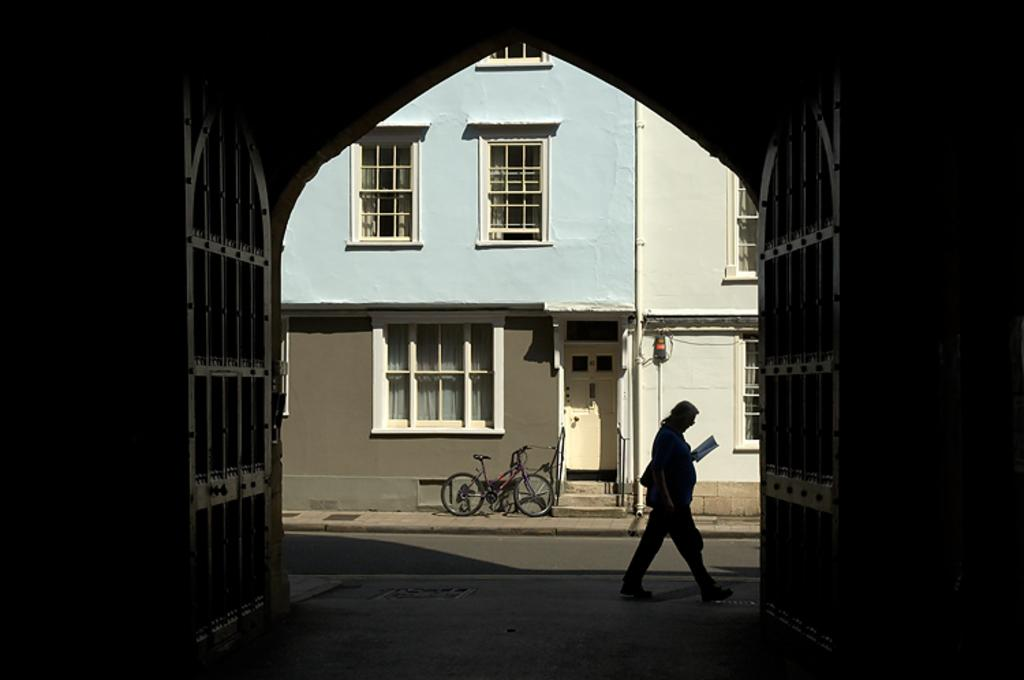What is the status of the gate in the image? The gate is open in the image. What is the person in the image doing? The person is walking and reading a book in the image. What is the person holding while walking? The person is holding a book while walking. What is the person doing with the book? The person is reading the book. What can be seen in the background of the image? There is a building in the background of the image. Is there any mode of transportation visible in the image? Yes, there is a bicycle in the image. Where is the kitty playing in the image? There is no kitty present in the image. How many lizards can be seen crawling on the building in the background? There are no lizards visible in the image, and the building is in the background. What type of furniture can be seen in the bedroom in the image? There is no bedroom present in the image. 